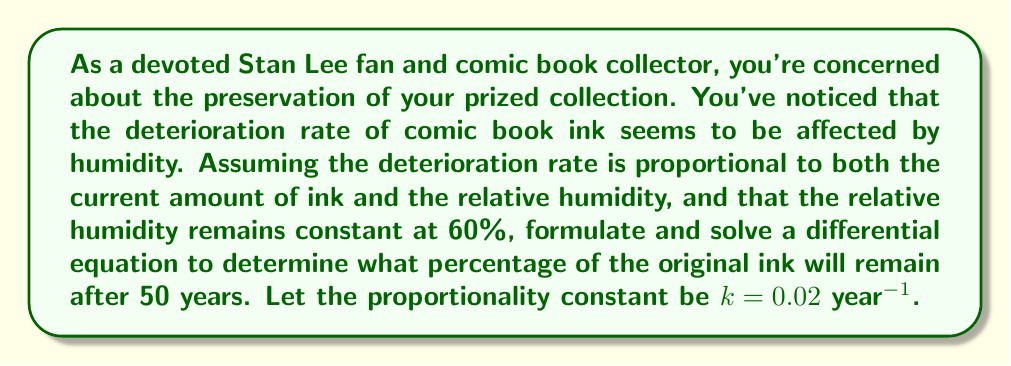Provide a solution to this math problem. Let's approach this problem step-by-step:

1) Let $I(t)$ be the amount of ink at time $t$ in years, and $I_0$ be the initial amount of ink.

2) The rate of change of ink with respect to time is proportional to both the current amount of ink and the relative humidity. We can express this as:

   $$\frac{dI}{dt} = -kHI$$

   where $k$ is the proportionality constant and $H$ is the relative humidity.

3) Given:
   - $k = 0.02$ year$^{-1}$
   - $H = 60\% = 0.6$
   - Initial condition: $I(0) = I_0$

4) Substituting these values into our differential equation:

   $$\frac{dI}{dt} = -0.02 \cdot 0.6 \cdot I = -0.012I$$

5) This is a separable differential equation. Let's solve it:

   $$\frac{dI}{I} = -0.012dt$$

6) Integrating both sides:

   $$\int \frac{dI}{I} = \int -0.012dt$$
   $$\ln|I| = -0.012t + C$$

7) Using the initial condition $I(0) = I_0$, we can find $C$:

   $$\ln|I_0| = C$$

8) Substituting back:

   $$\ln|I| = -0.012t + \ln|I_0|$$

9) Exponentiating both sides:

   $$I = I_0e^{-0.012t}$$

10) To find the percentage of ink remaining after 50 years, we calculate:

    $$\frac{I(50)}{I_0} \cdot 100\% = e^{-0.012 \cdot 50} \cdot 100\% \approx 54.88\%$$
Answer: Approximately 54.88% of the original ink will remain after 50 years. 